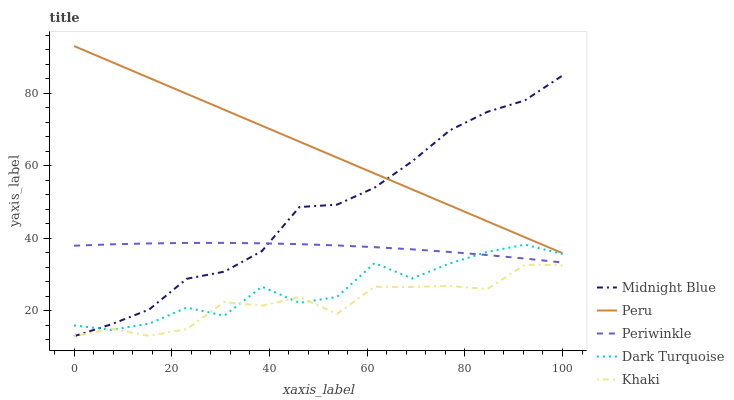Does Khaki have the minimum area under the curve?
Answer yes or no. Yes. Does Peru have the maximum area under the curve?
Answer yes or no. Yes. Does Periwinkle have the minimum area under the curve?
Answer yes or no. No. Does Periwinkle have the maximum area under the curve?
Answer yes or no. No. Is Peru the smoothest?
Answer yes or no. Yes. Is Dark Turquoise the roughest?
Answer yes or no. Yes. Is Khaki the smoothest?
Answer yes or no. No. Is Khaki the roughest?
Answer yes or no. No. Does Khaki have the lowest value?
Answer yes or no. Yes. Does Periwinkle have the lowest value?
Answer yes or no. No. Does Peru have the highest value?
Answer yes or no. Yes. Does Periwinkle have the highest value?
Answer yes or no. No. Is Dark Turquoise less than Peru?
Answer yes or no. Yes. Is Peru greater than Dark Turquoise?
Answer yes or no. Yes. Does Midnight Blue intersect Periwinkle?
Answer yes or no. Yes. Is Midnight Blue less than Periwinkle?
Answer yes or no. No. Is Midnight Blue greater than Periwinkle?
Answer yes or no. No. Does Dark Turquoise intersect Peru?
Answer yes or no. No. 